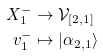Convert formula to latex. <formula><loc_0><loc_0><loc_500><loc_500>X _ { 1 } ^ { - } & \rightarrow \mathcal { V } _ { [ 2 , 1 ] } \\ v ^ { - } _ { 1 } & \mapsto | \alpha _ { 2 , 1 } \rangle</formula> 